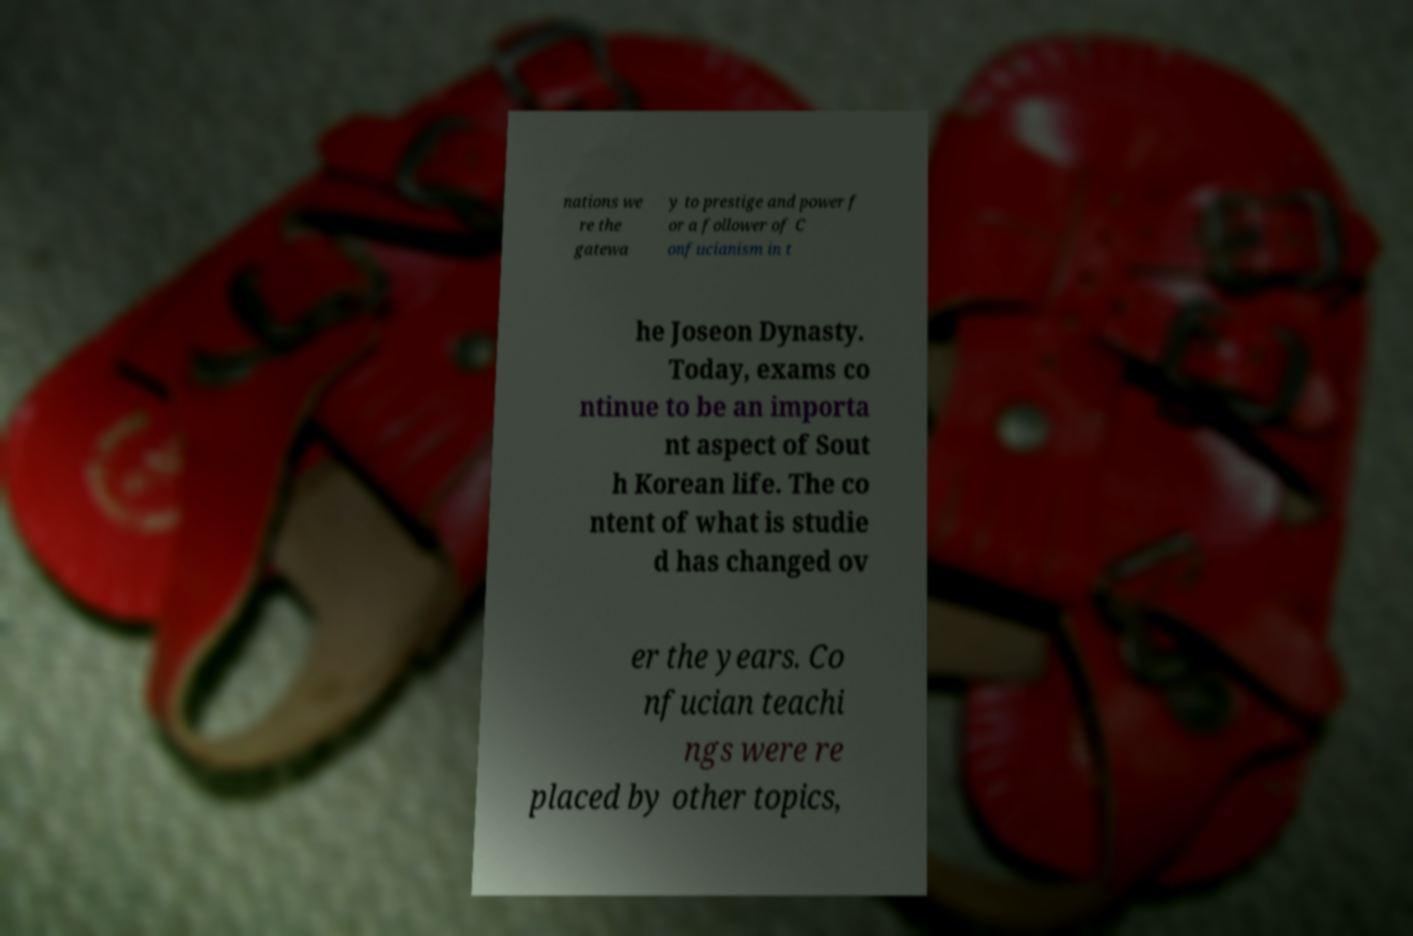Please identify and transcribe the text found in this image. nations we re the gatewa y to prestige and power f or a follower of C onfucianism in t he Joseon Dynasty. Today, exams co ntinue to be an importa nt aspect of Sout h Korean life. The co ntent of what is studie d has changed ov er the years. Co nfucian teachi ngs were re placed by other topics, 